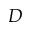Convert formula to latex. <formula><loc_0><loc_0><loc_500><loc_500>D</formula> 